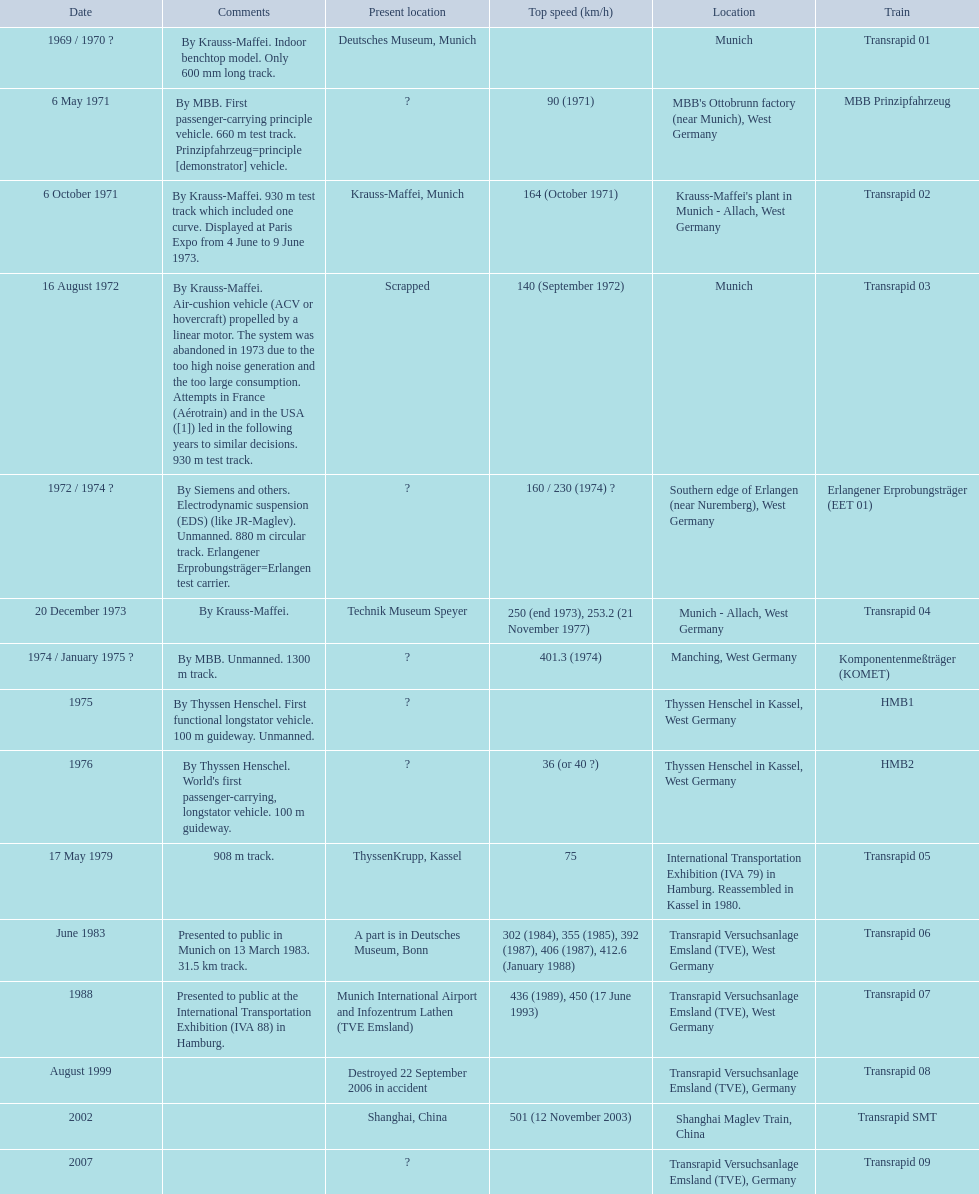What are all trains? Transrapid 01, MBB Prinzipfahrzeug, Transrapid 02, Transrapid 03, Erlangener Erprobungsträger (EET 01), Transrapid 04, Komponentenmeßträger (KOMET), HMB1, HMB2, Transrapid 05, Transrapid 06, Transrapid 07, Transrapid 08, Transrapid SMT, Transrapid 09. Which of all location of trains are known? Deutsches Museum, Munich, Krauss-Maffei, Munich, Scrapped, Technik Museum Speyer, ThyssenKrupp, Kassel, A part is in Deutsches Museum, Bonn, Munich International Airport and Infozentrum Lathen (TVE Emsland), Destroyed 22 September 2006 in accident, Shanghai, China. I'm looking to parse the entire table for insights. Could you assist me with that? {'header': ['Date', 'Comments', 'Present location', 'Top speed (km/h)', 'Location', 'Train'], 'rows': [['1969 / 1970\xa0?', 'By Krauss-Maffei. Indoor benchtop model. Only 600\xa0mm long track.', 'Deutsches Museum, Munich', '', 'Munich', 'Transrapid 01'], ['6 May 1971', 'By MBB. First passenger-carrying principle vehicle. 660 m test track. Prinzipfahrzeug=principle [demonstrator] vehicle.', '?', '90 (1971)', "MBB's Ottobrunn factory (near Munich), West Germany", 'MBB Prinzipfahrzeug'], ['6 October 1971', 'By Krauss-Maffei. 930 m test track which included one curve. Displayed at Paris Expo from 4 June to 9 June 1973.', 'Krauss-Maffei, Munich', '164 (October 1971)', "Krauss-Maffei's plant in Munich - Allach, West Germany", 'Transrapid 02'], ['16 August 1972', 'By Krauss-Maffei. Air-cushion vehicle (ACV or hovercraft) propelled by a linear motor. The system was abandoned in 1973 due to the too high noise generation and the too large consumption. Attempts in France (Aérotrain) and in the USA ([1]) led in the following years to similar decisions. 930 m test track.', 'Scrapped', '140 (September 1972)', 'Munich', 'Transrapid 03'], ['1972 / 1974\xa0?', 'By Siemens and others. Electrodynamic suspension (EDS) (like JR-Maglev). Unmanned. 880 m circular track. Erlangener Erprobungsträger=Erlangen test carrier.', '?', '160 / 230 (1974)\xa0?', 'Southern edge of Erlangen (near Nuremberg), West Germany', 'Erlangener Erprobungsträger (EET 01)'], ['20 December 1973', 'By Krauss-Maffei.', 'Technik Museum Speyer', '250 (end 1973), 253.2 (21 November 1977)', 'Munich - Allach, West Germany', 'Transrapid 04'], ['1974 / January 1975\xa0?', 'By MBB. Unmanned. 1300 m track.', '?', '401.3 (1974)', 'Manching, West Germany', 'Komponentenmeßträger (KOMET)'], ['1975', 'By Thyssen Henschel. First functional longstator vehicle. 100 m guideway. Unmanned.', '?', '', 'Thyssen Henschel in Kassel, West Germany', 'HMB1'], ['1976', "By Thyssen Henschel. World's first passenger-carrying, longstator vehicle. 100 m guideway.", '?', '36 (or 40\xa0?)', 'Thyssen Henschel in Kassel, West Germany', 'HMB2'], ['17 May 1979', '908 m track.', 'ThyssenKrupp, Kassel', '75', 'International Transportation Exhibition (IVA 79) in Hamburg. Reassembled in Kassel in 1980.', 'Transrapid 05'], ['June 1983', 'Presented to public in Munich on 13 March 1983. 31.5\xa0km track.', 'A part is in Deutsches Museum, Bonn', '302 (1984), 355 (1985), 392 (1987), 406 (1987), 412.6 (January 1988)', 'Transrapid Versuchsanlage Emsland (TVE), West Germany', 'Transrapid 06'], ['1988', 'Presented to public at the International Transportation Exhibition (IVA 88) in Hamburg.', 'Munich International Airport and Infozentrum Lathen (TVE Emsland)', '436 (1989), 450 (17 June 1993)', 'Transrapid Versuchsanlage Emsland (TVE), West Germany', 'Transrapid 07'], ['August 1999', '', 'Destroyed 22 September 2006 in accident', '', 'Transrapid Versuchsanlage Emsland (TVE), Germany', 'Transrapid 08'], ['2002', '', 'Shanghai, China', '501 (12 November 2003)', 'Shanghai Maglev Train, China', 'Transrapid SMT'], ['2007', '', '?', '', 'Transrapid Versuchsanlage Emsland (TVE), Germany', 'Transrapid 09']]} Which of those trains were scrapped? Transrapid 03. 